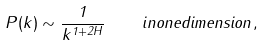Convert formula to latex. <formula><loc_0><loc_0><loc_500><loc_500>P ( k ) \sim \frac { 1 } { k ^ { 1 + 2 H } } \quad i n o n e d i m e n s i o n \, ,</formula> 